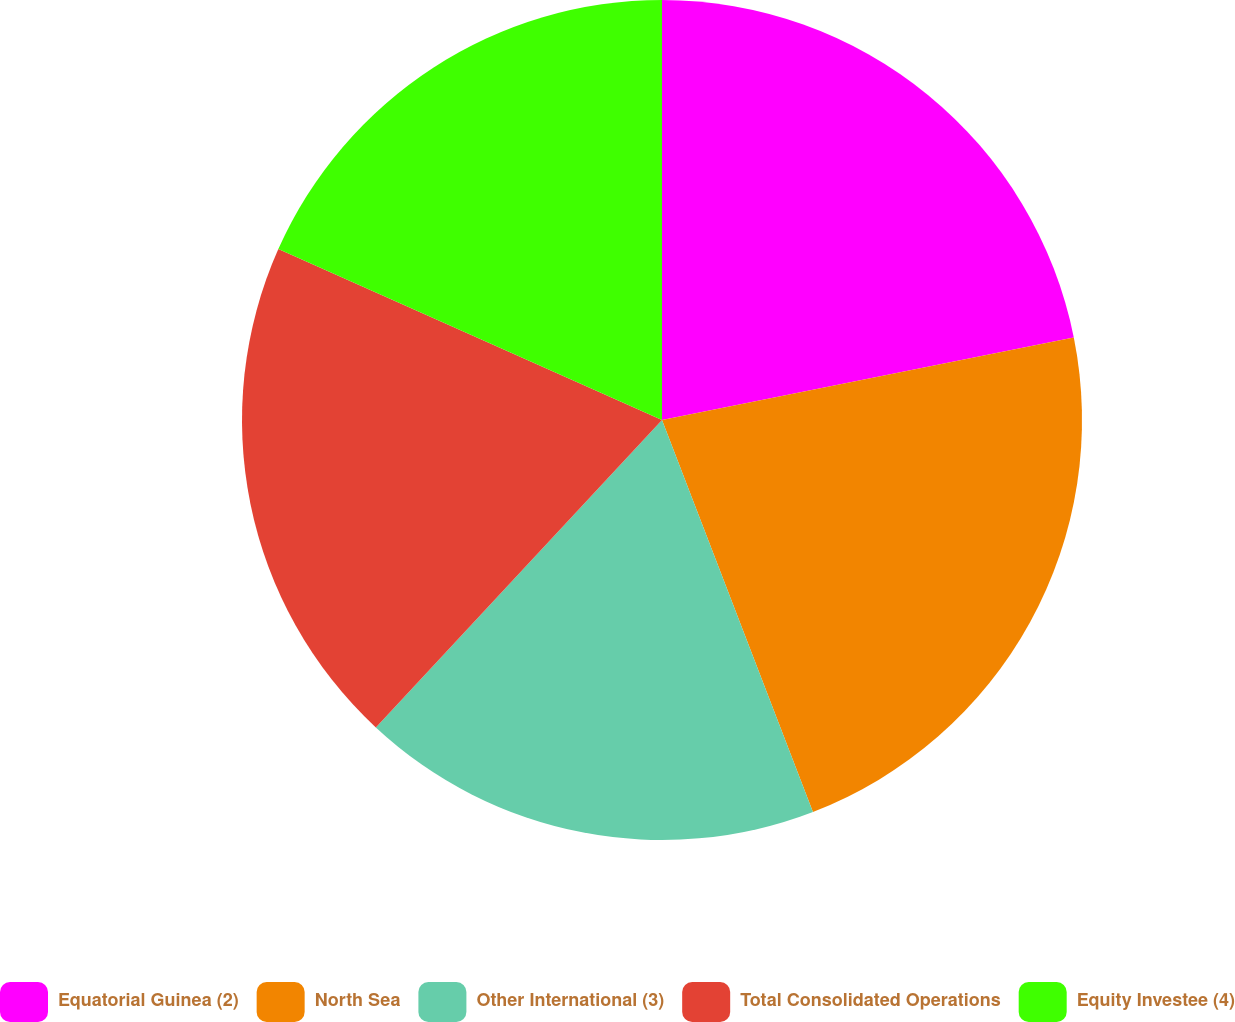<chart> <loc_0><loc_0><loc_500><loc_500><pie_chart><fcel>Equatorial Guinea (2)<fcel>North Sea<fcel>Other International (3)<fcel>Total Consolidated Operations<fcel>Equity Investee (4)<nl><fcel>21.85%<fcel>22.3%<fcel>17.78%<fcel>19.74%<fcel>18.33%<nl></chart> 